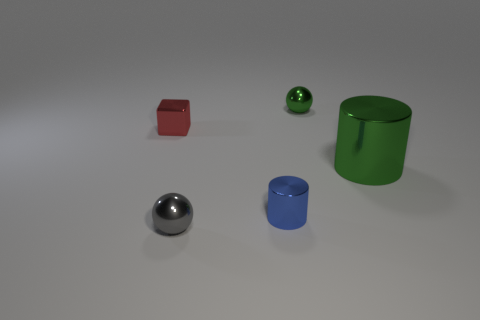What's the texture like on the objects? The objects have a smooth, reflective surface quality. The metallic sheen on the sphere and cylinder suggests a polished metal texture, while the matte finish of the cube and the cylinder provides a contrast. 